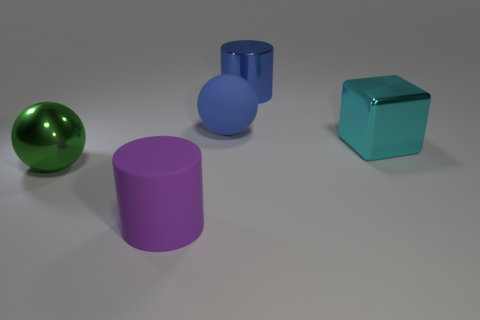Add 1 shiny objects. How many objects exist? 6 Subtract all blocks. How many objects are left? 4 Add 4 big objects. How many big objects exist? 9 Subtract 1 purple cylinders. How many objects are left? 4 Subtract all tiny purple objects. Subtract all rubber things. How many objects are left? 3 Add 2 large objects. How many large objects are left? 7 